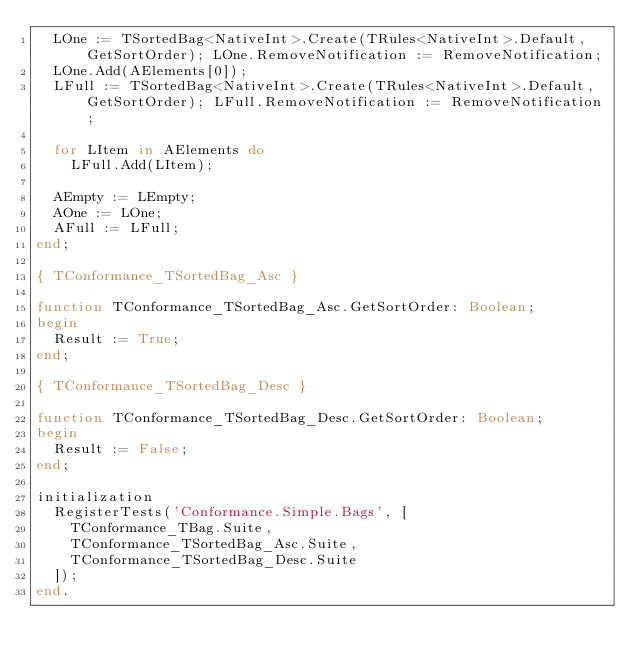<code> <loc_0><loc_0><loc_500><loc_500><_Pascal_>  LOne := TSortedBag<NativeInt>.Create(TRules<NativeInt>.Default, GetSortOrder); LOne.RemoveNotification := RemoveNotification;
  LOne.Add(AElements[0]);
  LFull := TSortedBag<NativeInt>.Create(TRules<NativeInt>.Default, GetSortOrder); LFull.RemoveNotification := RemoveNotification;

  for LItem in AElements do
    LFull.Add(LItem);

  AEmpty := LEmpty;
  AOne := LOne;
  AFull := LFull;
end;

{ TConformance_TSortedBag_Asc }

function TConformance_TSortedBag_Asc.GetSortOrder: Boolean;
begin
  Result := True;
end;

{ TConformance_TSortedBag_Desc }

function TConformance_TSortedBag_Desc.GetSortOrder: Boolean;
begin
  Result := False;
end;

initialization
  RegisterTests('Conformance.Simple.Bags', [
    TConformance_TBag.Suite,
    TConformance_TSortedBag_Asc.Suite,
    TConformance_TSortedBag_Desc.Suite
  ]);
end.

</code> 